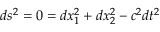Convert formula to latex. <formula><loc_0><loc_0><loc_500><loc_500>d s ^ { 2 } = 0 = d x _ { 1 } ^ { 2 } + d x _ { 2 } ^ { 2 } - c ^ { 2 } d t ^ { 2 }</formula> 